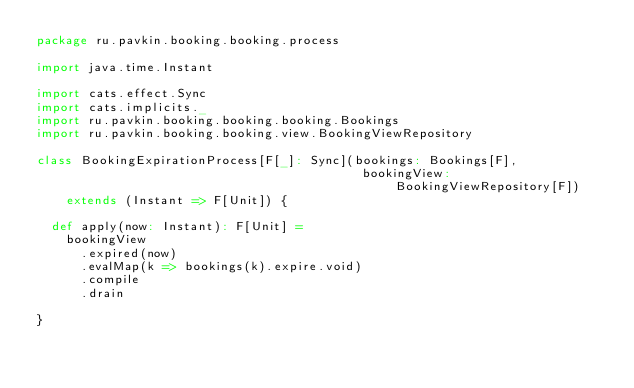Convert code to text. <code><loc_0><loc_0><loc_500><loc_500><_Scala_>package ru.pavkin.booking.booking.process

import java.time.Instant

import cats.effect.Sync
import cats.implicits._
import ru.pavkin.booking.booking.booking.Bookings
import ru.pavkin.booking.booking.view.BookingViewRepository

class BookingExpirationProcess[F[_]: Sync](bookings: Bookings[F],
                                            bookingView: BookingViewRepository[F])
    extends (Instant => F[Unit]) {

  def apply(now: Instant): F[Unit] =
    bookingView
      .expired(now)
      .evalMap(k => bookings(k).expire.void)
      .compile
      .drain

}
</code> 